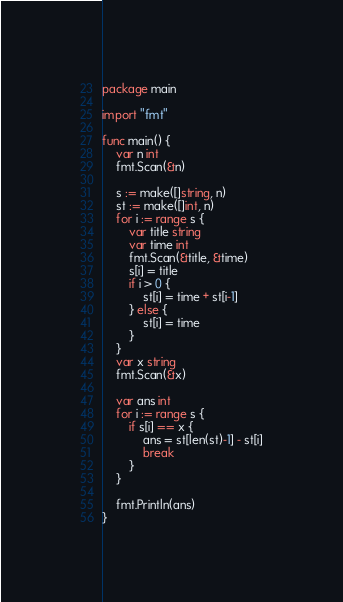Convert code to text. <code><loc_0><loc_0><loc_500><loc_500><_Go_>package main

import "fmt"

func main() {
	var n int
	fmt.Scan(&n)

	s := make([]string, n)
	st := make([]int, n)
	for i := range s {
		var title string
		var time int
		fmt.Scan(&title, &time)
		s[i] = title
		if i > 0 {
			st[i] = time + st[i-1]
		} else {
			st[i] = time
		}
	}
	var x string
	fmt.Scan(&x)

	var ans int
	for i := range s {
		if s[i] == x {
			ans = st[len(st)-1] - st[i]
			break
		}
	}

	fmt.Println(ans)
}
</code> 